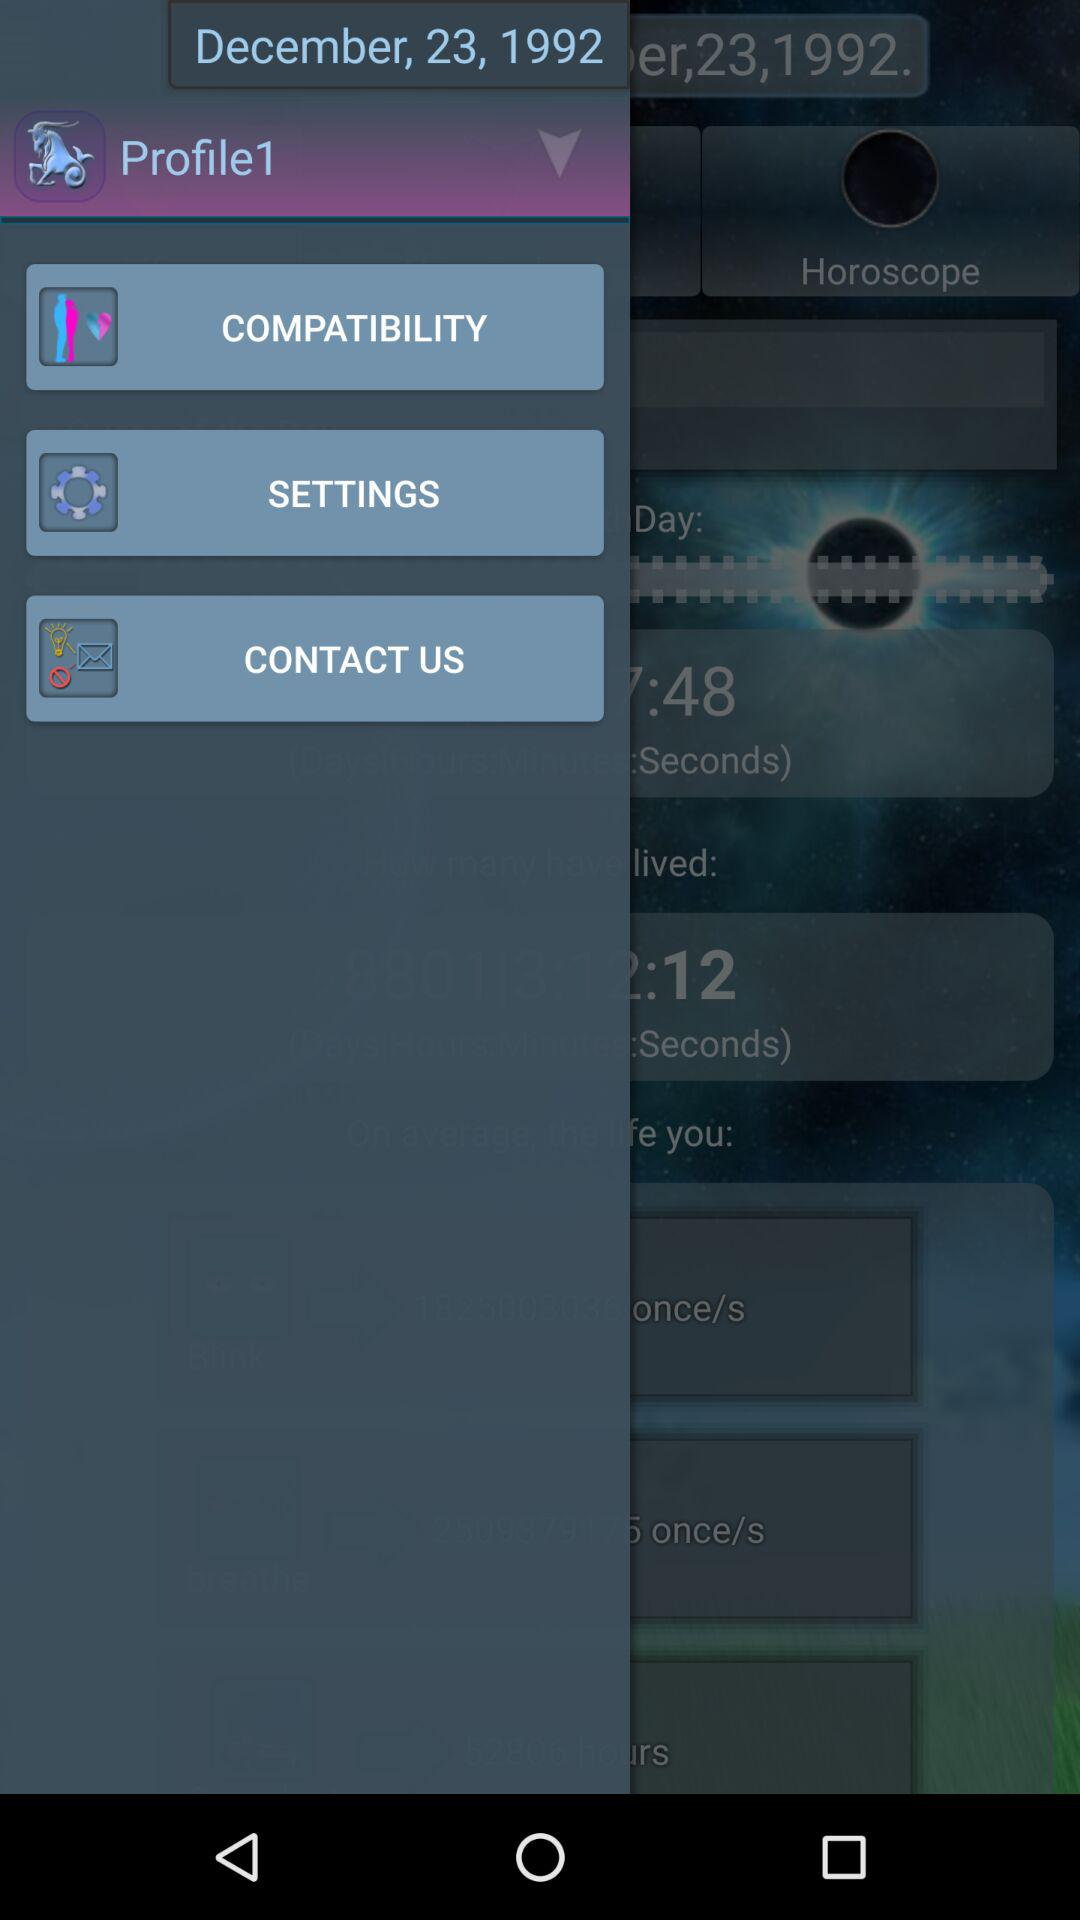What is the date? The date is December 23, 1992. 